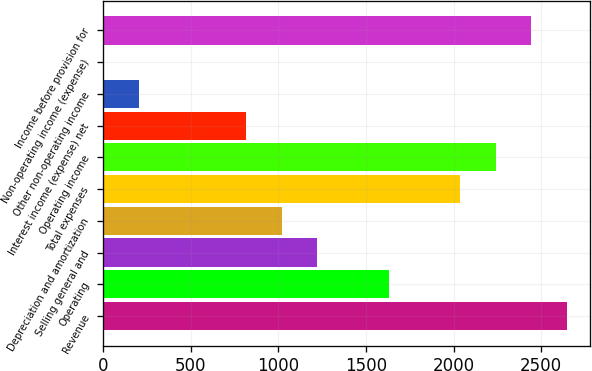<chart> <loc_0><loc_0><loc_500><loc_500><bar_chart><fcel>Revenue<fcel>Operating<fcel>Selling general and<fcel>Depreciation and amortization<fcel>Total expenses<fcel>Operating income<fcel>Interest income (expense) net<fcel>Other non-operating income<fcel>Non-operating income (expense)<fcel>Income before provision for<nl><fcel>2647.93<fcel>1629.88<fcel>1222.66<fcel>1019.05<fcel>2037.1<fcel>2240.71<fcel>815.44<fcel>204.61<fcel>1<fcel>2444.32<nl></chart> 